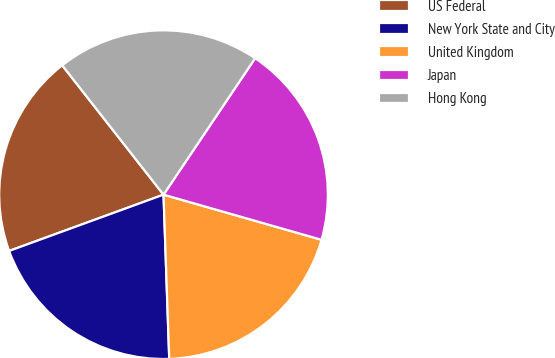Convert chart. <chart><loc_0><loc_0><loc_500><loc_500><pie_chart><fcel>US Federal<fcel>New York State and City<fcel>United Kingdom<fcel>Japan<fcel>Hong Kong<nl><fcel>19.99%<fcel>19.99%<fcel>20.02%<fcel>20.02%<fcel>19.99%<nl></chart> 